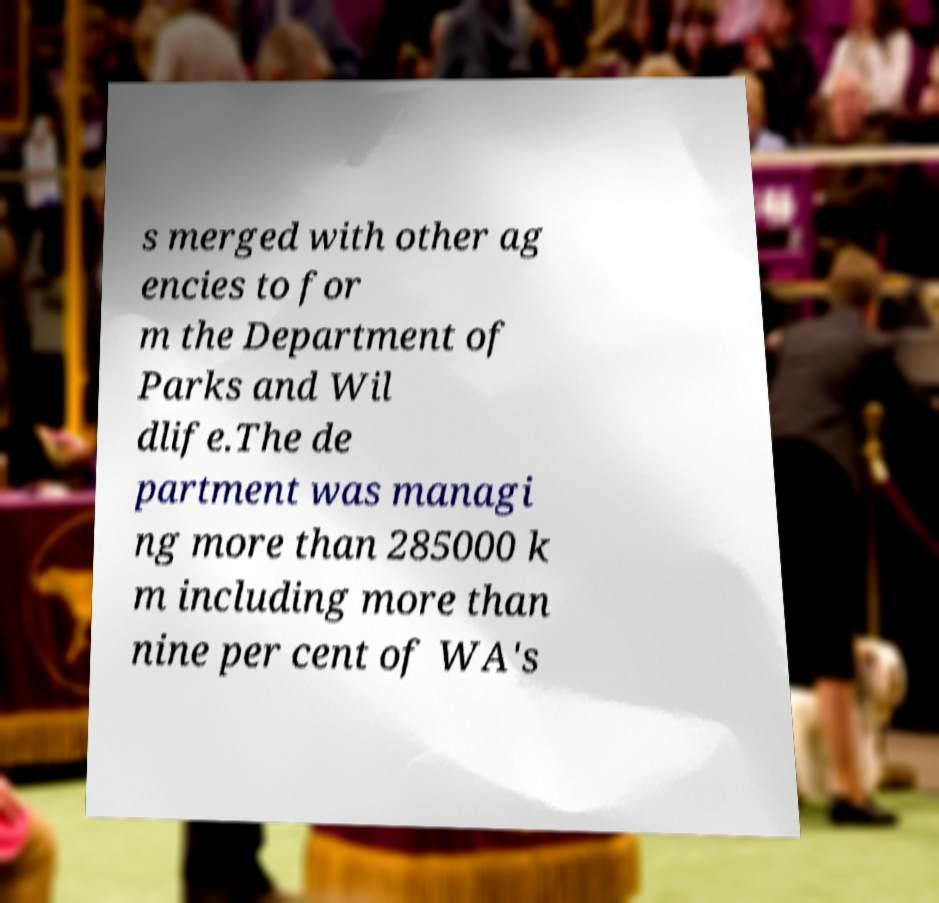For documentation purposes, I need the text within this image transcribed. Could you provide that? s merged with other ag encies to for m the Department of Parks and Wil dlife.The de partment was managi ng more than 285000 k m including more than nine per cent of WA's 